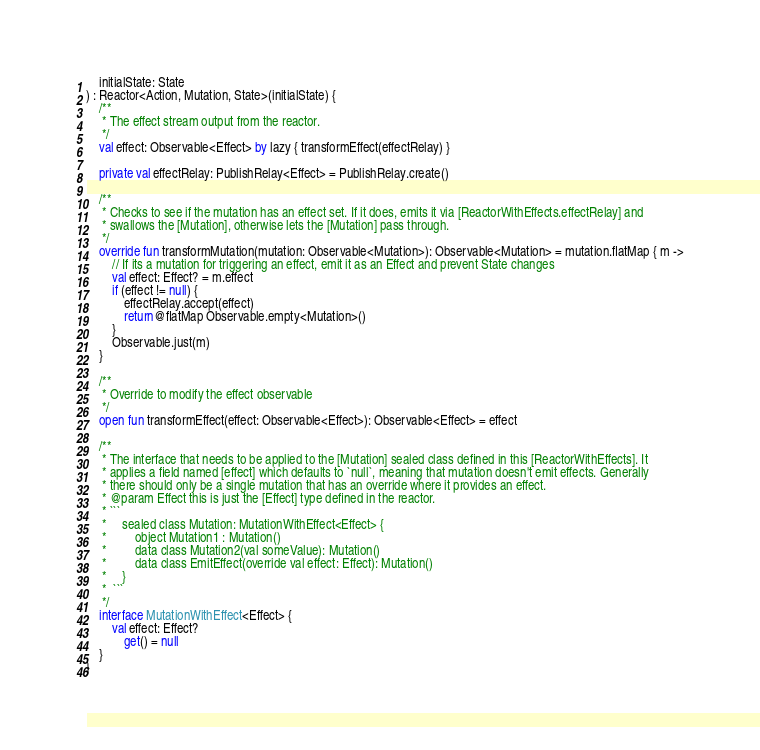Convert code to text. <code><loc_0><loc_0><loc_500><loc_500><_Kotlin_>    initialState: State
) : Reactor<Action, Mutation, State>(initialState) {
    /**
     * The effect stream output from the reactor.
     */
    val effect: Observable<Effect> by lazy { transformEffect(effectRelay) }

    private val effectRelay: PublishRelay<Effect> = PublishRelay.create()

    /**
     * Checks to see if the mutation has an effect set. If it does, emits it via [ReactorWithEffects.effectRelay] and
     * swallows the [Mutation], otherwise lets the [Mutation] pass through.
     */
    override fun transformMutation(mutation: Observable<Mutation>): Observable<Mutation> = mutation.flatMap { m ->
        // If its a mutation for triggering an effect, emit it as an Effect and prevent State changes
        val effect: Effect? = m.effect
        if (effect != null) {
            effectRelay.accept(effect)
            return@flatMap Observable.empty<Mutation>()
        }
        Observable.just(m)
    }

    /**
     * Override to modify the effect observable
     */
    open fun transformEffect(effect: Observable<Effect>): Observable<Effect> = effect

    /**
     * The interface that needs to be applied to the [Mutation] sealed class defined in this [ReactorWithEffects]. It
     * applies a field named [effect] which defaults to `null`, meaning that mutation doesn't emit effects. Generally
     * there should only be a single mutation that has an override where it provides an effect.
     * @param Effect this is just the [Effect] type defined in the reactor.
     * ```
     *     sealed class Mutation: MutationWithEffect<Effect> {
     *         object Mutation1 : Mutation()
     *         data class Mutation2(val someValue): Mutation()
     *         data class EmitEffect(override val effect: Effect): Mutation()
     *     }
     *  ```
     */
    interface MutationWithEffect<Effect> {
        val effect: Effect?
            get() = null
    }
}
</code> 